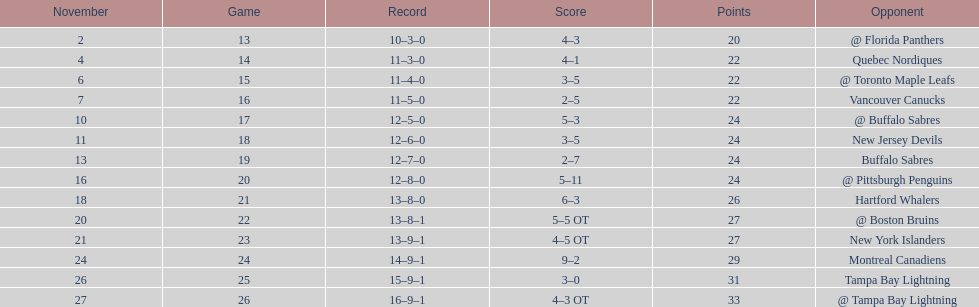Which was the only team in the atlantic division in the 1993-1994 season to acquire less points than the philadelphia flyers? Tampa Bay Lightning. 